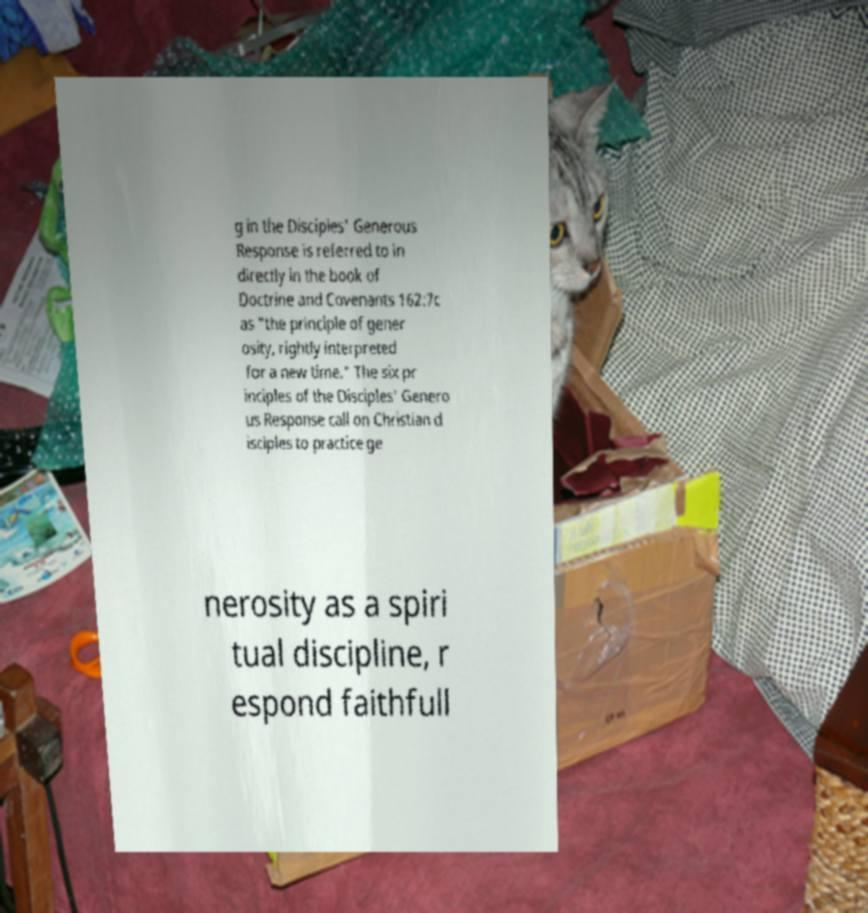What messages or text are displayed in this image? I need them in a readable, typed format. g in the Disciples' Generous Response is referred to in directly in the book of Doctrine and Covenants 162:7c as "the principle of gener osity, rightly interpreted for a new time." The six pr inciples of the Disciples' Genero us Response call on Christian d isciples to practice ge nerosity as a spiri tual discipline, r espond faithfull 